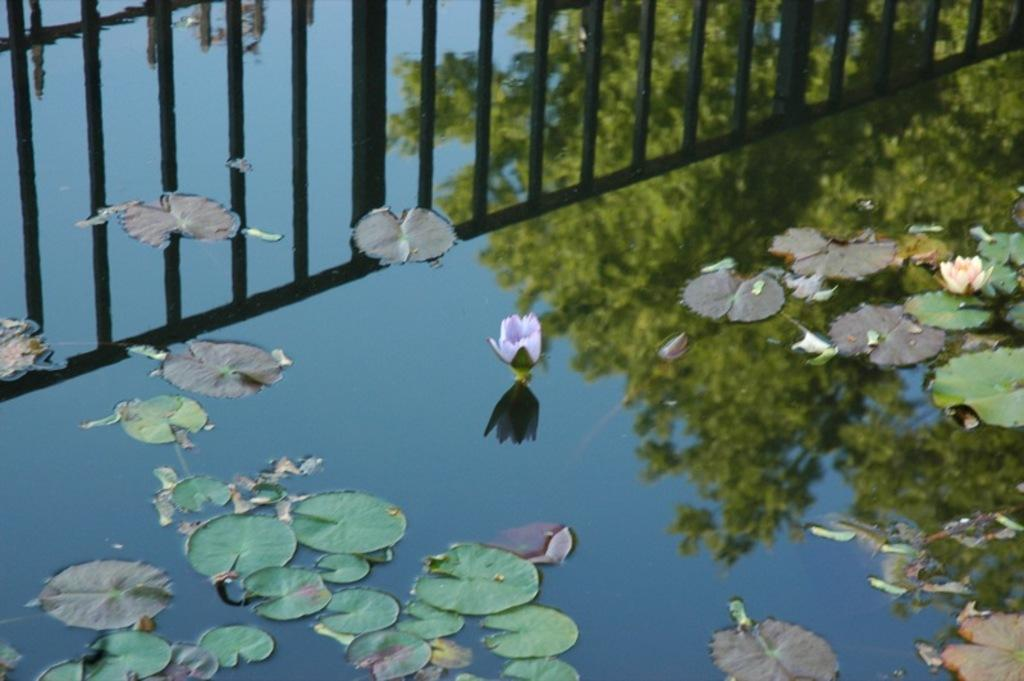What is the primary element visible in the image? There is water in the image. What is floating on the water? Leaves and flowers are present on the water. Are there any other objects on the water? Yes, there are other objects on the water. What can be observed on the surface of the water? Reflections are visible on the water. What type of chalk is being used to draw on the water? There is no chalk present in the image, and therefore no drawing activity can be observed. 